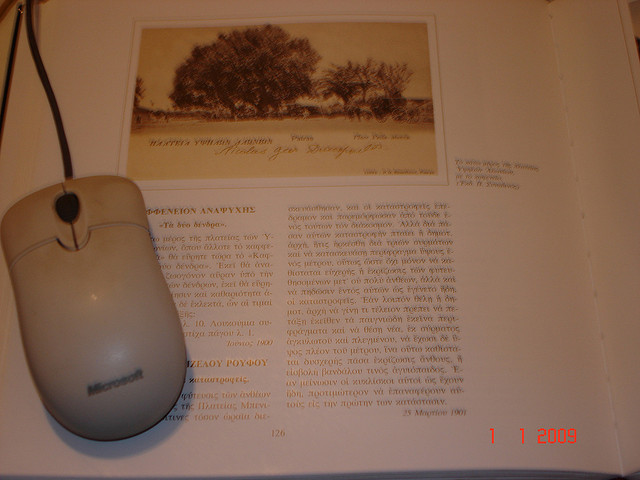What might the symbolism of the lone tree in the sketch signify in the context of the book's theme? The lone tree in the sketch could represent themes of isolation, resilience, or perhaps the stark beauty of nature. It might be linked to key narrative elements in the book where these themes are explored, serving as a poignant visual metaphor for readers. 